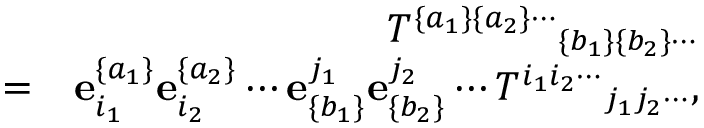Convert formula to latex. <formula><loc_0><loc_0><loc_500><loc_500>\begin{array} { r l r } & { { T ^ { \{ a _ { 1 } \} \{ a _ { 2 } \} \cdots } } _ { \{ b _ { 1 } \} \{ b _ { 2 } \} \cdots } } \\ & { = } & { { e } _ { i _ { 1 } } ^ { \{ a _ { 1 } \} } { e } _ { i _ { 2 } } ^ { \{ a _ { 2 } \} } \cdots { e } _ { \{ b _ { 1 } \} } ^ { j _ { 1 } } { e } _ { \{ b _ { 2 } \} } ^ { j _ { 2 } } \cdots { T ^ { i _ { 1 } i _ { 2 } \cdots } } _ { j _ { 1 } j _ { 2 } \cdots } , } \end{array}</formula> 